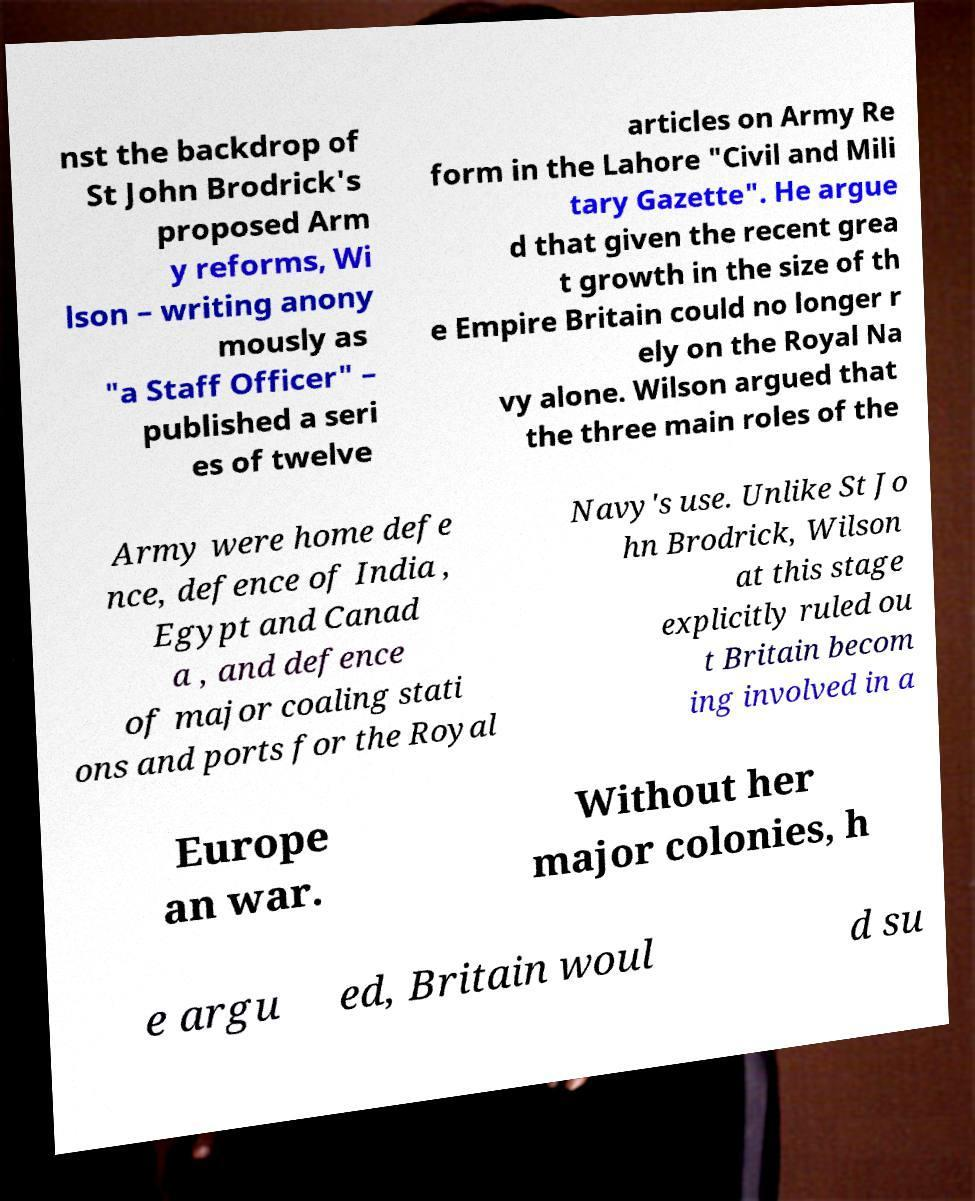Can you accurately transcribe the text from the provided image for me? nst the backdrop of St John Brodrick's proposed Arm y reforms, Wi lson – writing anony mously as "a Staff Officer" – published a seri es of twelve articles on Army Re form in the Lahore "Civil and Mili tary Gazette". He argue d that given the recent grea t growth in the size of th e Empire Britain could no longer r ely on the Royal Na vy alone. Wilson argued that the three main roles of the Army were home defe nce, defence of India , Egypt and Canad a , and defence of major coaling stati ons and ports for the Royal Navy's use. Unlike St Jo hn Brodrick, Wilson at this stage explicitly ruled ou t Britain becom ing involved in a Europe an war. Without her major colonies, h e argu ed, Britain woul d su 